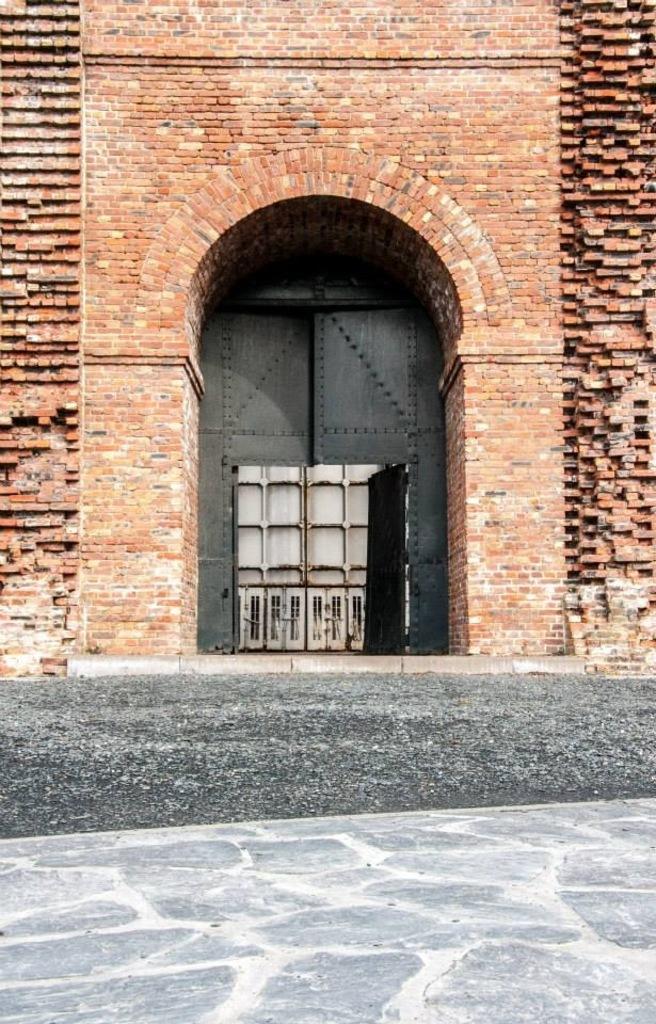In one or two sentences, can you explain what this image depicts? In this picture I can see there is a building and it has a brick wall, there is a door, there is soil on the floor. 